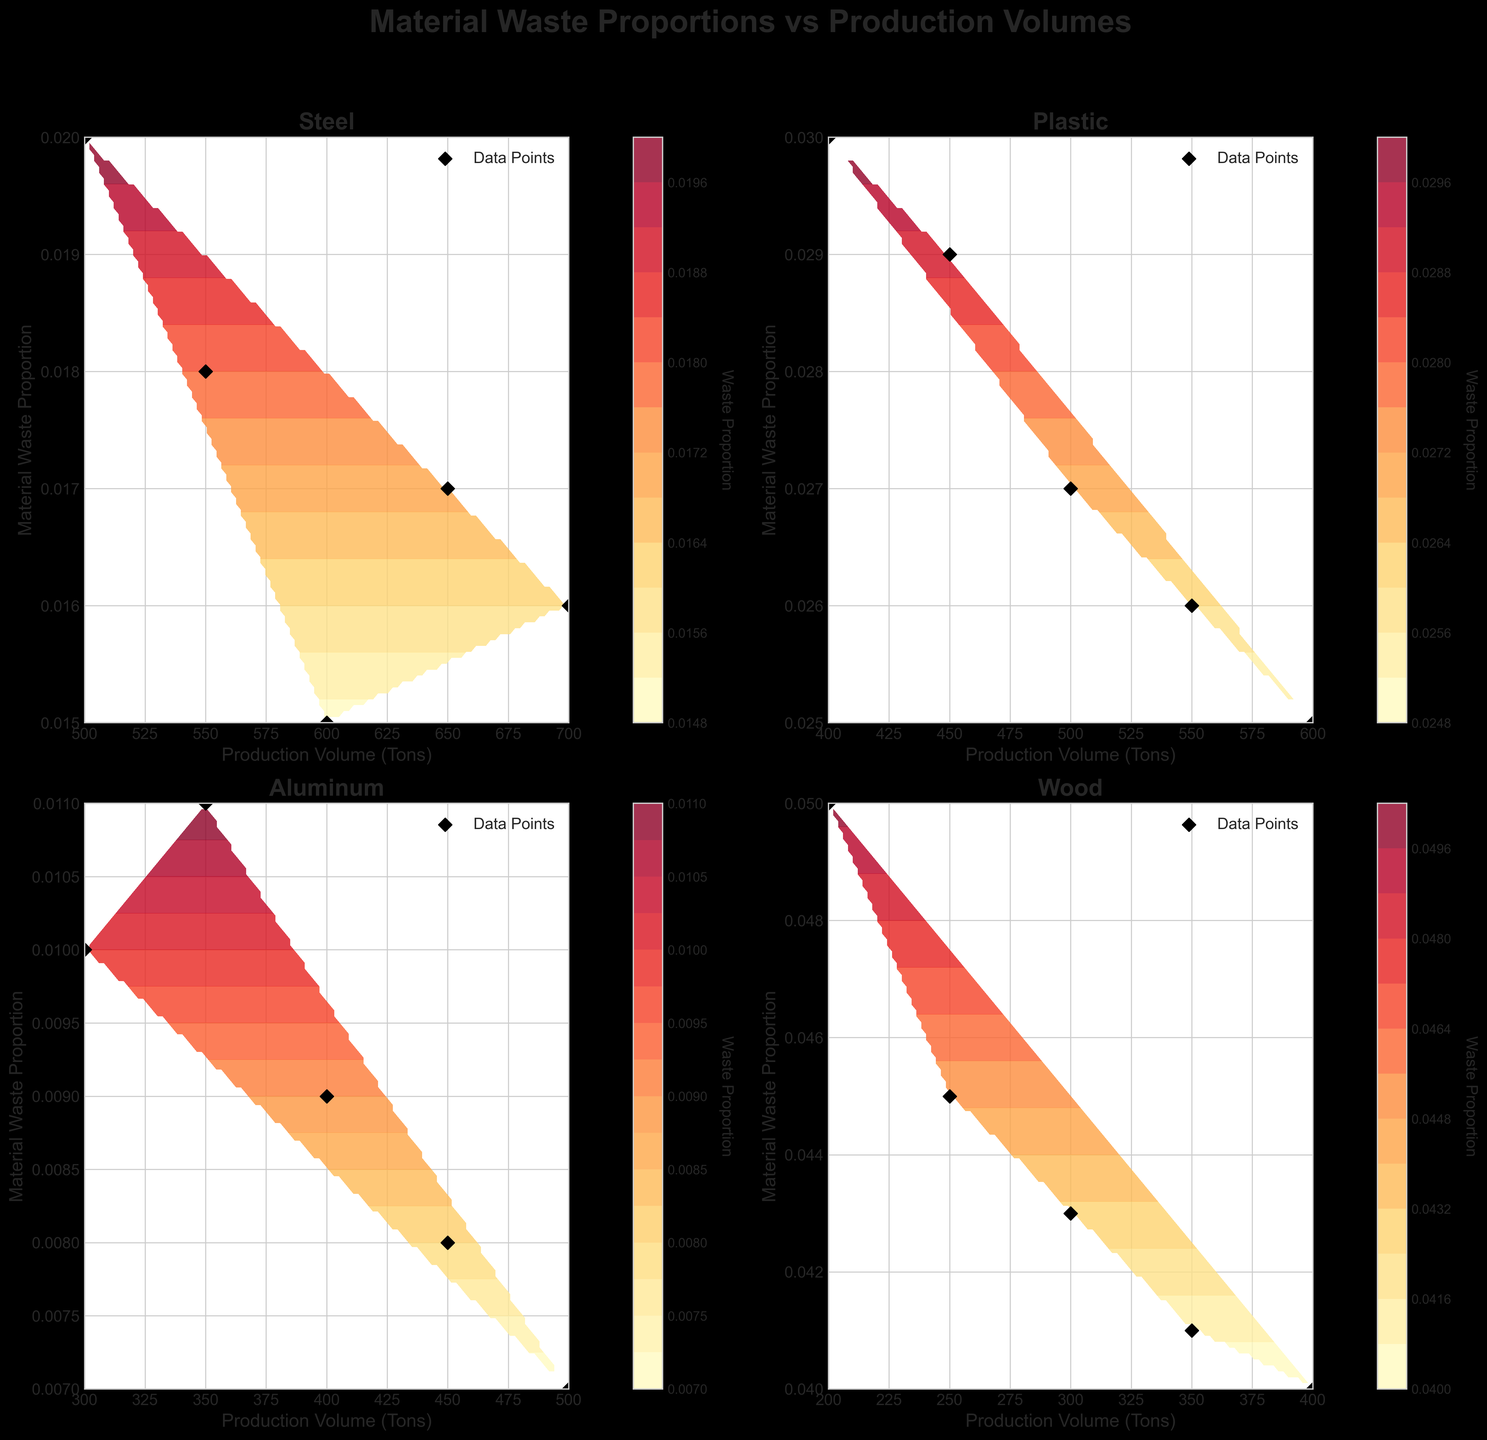What is the title of the figure? The title is located at the top of the figure, usually in bold and larger font than other text. It clearly states the overall subject of the plots.
Answer: Material Waste Proportions vs Production Volumes How many material types are displayed in the subplots? By looking at the titles of each subplot, we can count the distinct material types mentioned.
Answer: Four For Steel, what is the approximate range of Production Volume (Tons) shown in the subplot? Examine the x-axis of the Steel plot to identify the minimum and maximum values.
Answer: 500 to 700 Which material has the highest range of Material Waste Proportion in the subplots? By comparing the y-axis ranges of each subplot, we can identify which material has the highest spread in material waste proportion.
Answer: Wood How do the Material Waste Proportions generally change with increasing Production Volume for Aluminum? Observe the distribution of the scatter points in the Aluminum subplot, focusing on the trend seen as Production Volume increases along the x-axis.
Answer: They decrease Is there a material type that has a generally increasing Material Waste Proportion with increasing Production Volume? Look for any subplot where the trend shows an increasing proportion of material waste as production volumes increase.
Answer: No Compare the trend of Material Waste Proportion between Plastic and Steel, which material shows a consistent decrease in waste proportion as production volume increases? Examine both Plastic and Steel subplots and observe the general direction of the scatter points with increasing production volume.
Answer: Plastic Which material type shows the steepest decrease in Material Waste Proportion with increased Production Volume? Determine which subplot shows the sharpest decline in y-values as x-values increase.
Answer: Aluminum What is the approximate Production Volume at which Wood has a Material Waste Proportion of 0.041? Locate the value 0.041 on the y-axis of the Wood subplot, then trace it horizontally to the corresponding x-axis value.
Answer: 350 tons How many data points are there for each material in the subplots? Count the number of black diamond-shaped scatter points in any given subplot, since each represents a data point.
Answer: Five 